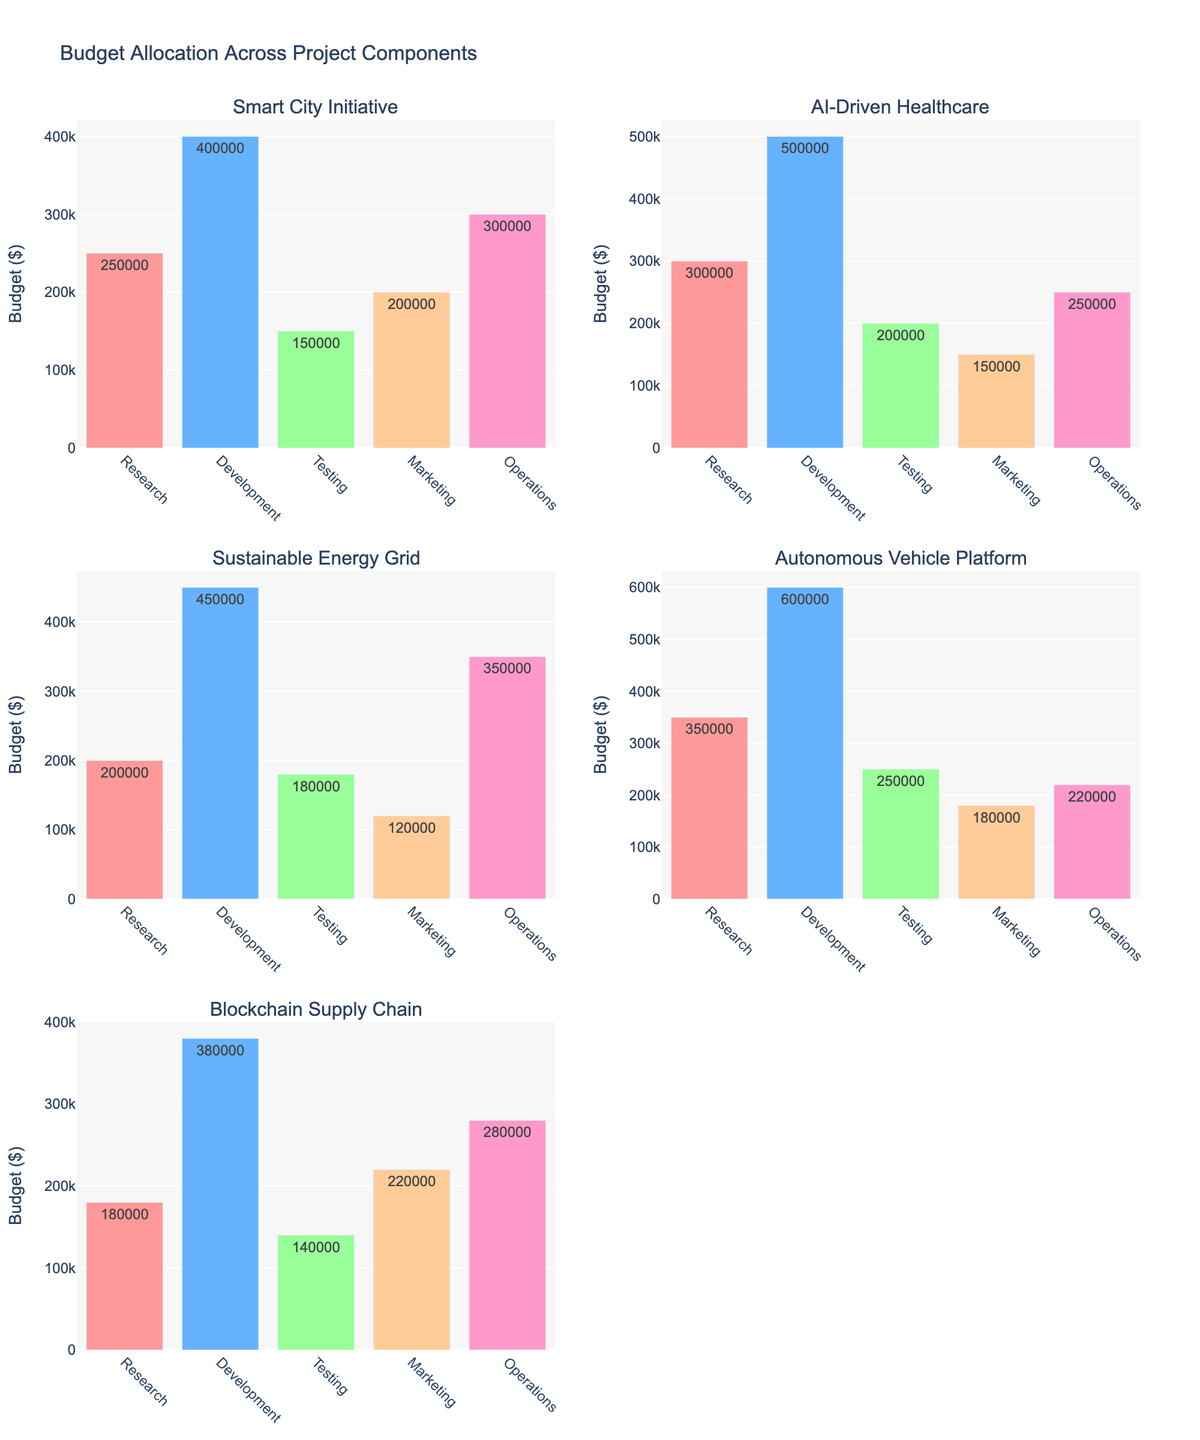what is the highest allocated budget among all the project components? Among all the project components, the highest allocated budget is found in the 'Development' component of the 'Autonomous Vehicle Platform' with $600,000, as shown in the subplot for the 'Autonomous Vehicle Platform'.
Answer: $600,000 Which project has the lowest budget for marketing? From the figure, the 'Sustainable Energy Grid' project has the lowest budget allocated for marketing, with $120,000. This is visible from the subplot for 'Sustainable Energy Grid'.
Answer: $120,000 Between 'Smart City Initiative' and 'Blockchain Supply Chain', which project has a higher total budget? To find the total budget, sum the budget allocations of each component for both projects: Smart City Initiative: $250,000 + $400,000 + $150,000 + $200,000 + $300,000 = $1,300,000. Blockchain Supply Chain: $180,000 + $380,000 + $140,000 + $220,000 + $280,000 = $1,200,000. 'Smart City Initiative' has a higher total budget.
Answer: Smart City Initiative How many projects have a budget allocation greater than $200,000 for the 'Testing' component? The projects with budgets greater than $200,000 for 'Testing' are 'AI-Driven Healthcare' ($200,000) and 'Autonomous Vehicle Platform' ($250,000). Therefore, the number of projects is two.
Answer: 2 Which project has the most evenly distributed budget across all components? By visually comparing, 'Blockchain Supply Chain' has the most evenly distributed budget, as the bars' heights in its subplot are relatively close compared to other projects.
Answer: Blockchain Supply Chain What is the average budget allocated for the 'Research' component across all projects? Sum the 'Research' component budget allocations and divide by the number of projects: ($250,000 + $300,000 + $200,000 + $350,000 + $180,000) / 5 = $1,280,000 / 5 = $256,000.
Answer: $256,000 Which project has the highest budget for 'Development' and what is this value? 'Autonomous Vehicle Platform' has the highest budget for the 'Development' component with $600,000, as seen in the subplot respectively titled.
Answer: Autonomous Vehicle Platform, $600,000 What is the difference between the highest and lowest budget allocations for 'Operations'? To find the difference, first identify the highest and lowest allocations for 'Operations': highest is 'Sustainable Energy Grid' ($350,000) and lowest is 'AI-Driven Healthcare' ($250,000). Difference = $350,000 - $250,000 = $100,000.
Answer: $100,000 For the 'Smart City Initiative', what is the total budget of all components excluding 'Development'? To find this, sum the budgets of all components excluding 'Development' for 'Smart City Initiative': $250,000 (Research) + $150,000 (Testing) + $200,000 (Marketing) + $300,000 (Operations) = $900,000.
Answer: $900,000 